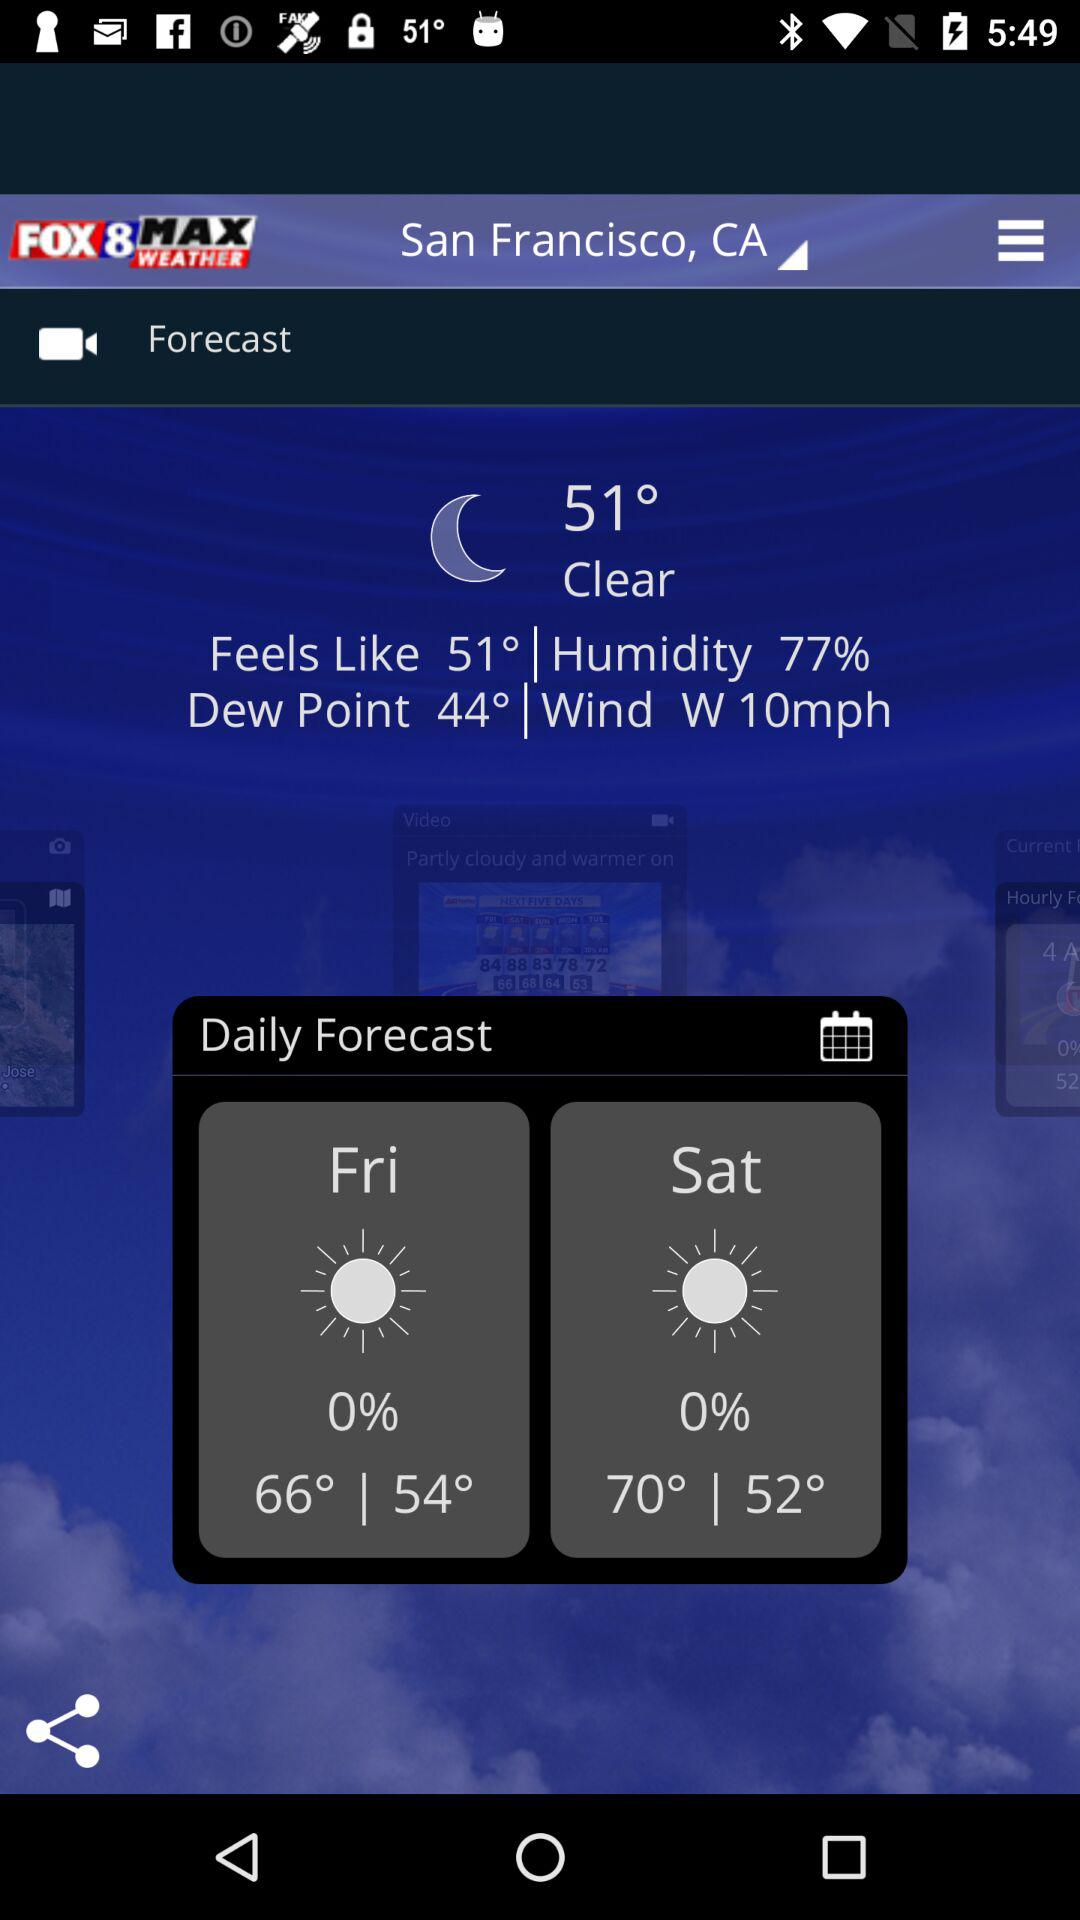What is the temperature today? The temperature today is 51°. 